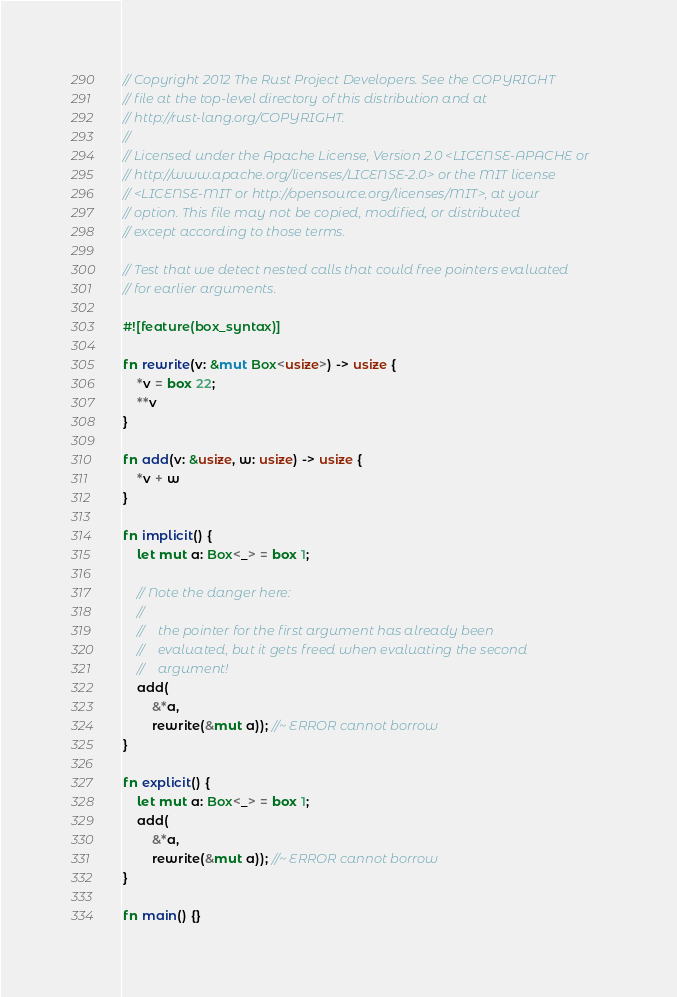<code> <loc_0><loc_0><loc_500><loc_500><_Rust_>// Copyright 2012 The Rust Project Developers. See the COPYRIGHT
// file at the top-level directory of this distribution and at
// http://rust-lang.org/COPYRIGHT.
//
// Licensed under the Apache License, Version 2.0 <LICENSE-APACHE or
// http://www.apache.org/licenses/LICENSE-2.0> or the MIT license
// <LICENSE-MIT or http://opensource.org/licenses/MIT>, at your
// option. This file may not be copied, modified, or distributed
// except according to those terms.

// Test that we detect nested calls that could free pointers evaluated
// for earlier arguments.

#![feature(box_syntax)]

fn rewrite(v: &mut Box<usize>) -> usize {
    *v = box 22;
    **v
}

fn add(v: &usize, w: usize) -> usize {
    *v + w
}

fn implicit() {
    let mut a: Box<_> = box 1;

    // Note the danger here:
    //
    //    the pointer for the first argument has already been
    //    evaluated, but it gets freed when evaluating the second
    //    argument!
    add(
        &*a,
        rewrite(&mut a)); //~ ERROR cannot borrow
}

fn explicit() {
    let mut a: Box<_> = box 1;
    add(
        &*a,
        rewrite(&mut a)); //~ ERROR cannot borrow
}

fn main() {}
</code> 